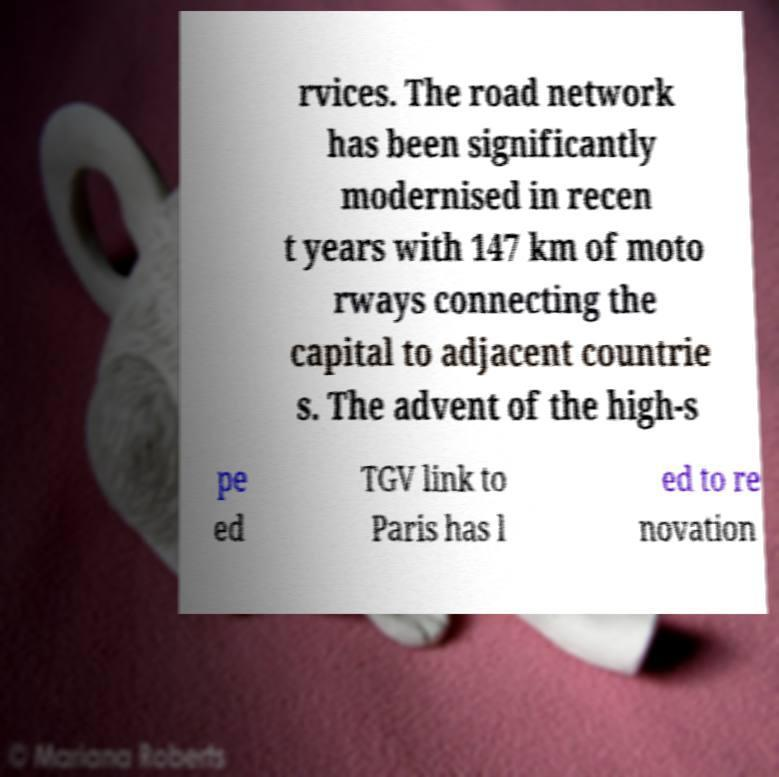Can you read and provide the text displayed in the image?This photo seems to have some interesting text. Can you extract and type it out for me? rvices. The road network has been significantly modernised in recen t years with 147 km of moto rways connecting the capital to adjacent countrie s. The advent of the high-s pe ed TGV link to Paris has l ed to re novation 